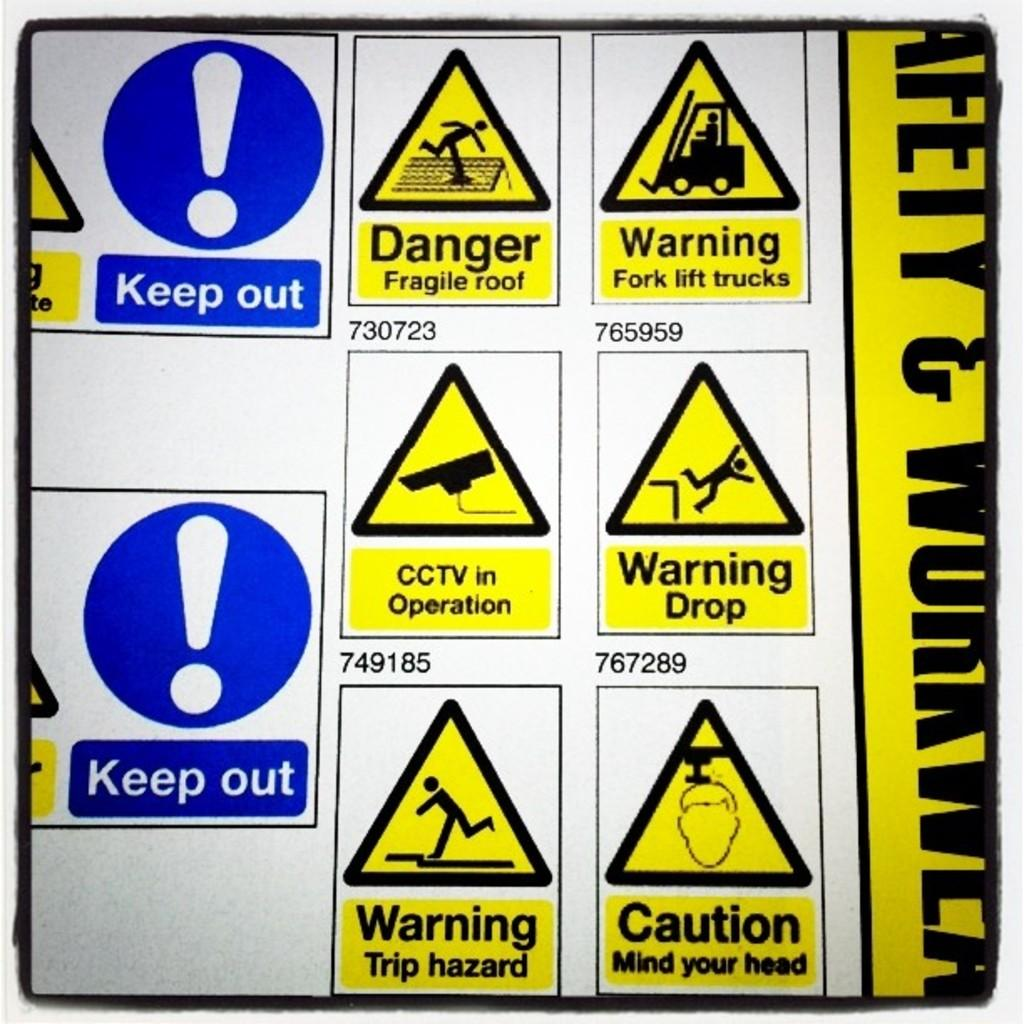<image>
Relay a brief, clear account of the picture shown. A page full of warning signs including keep out and danger fragile roof. 